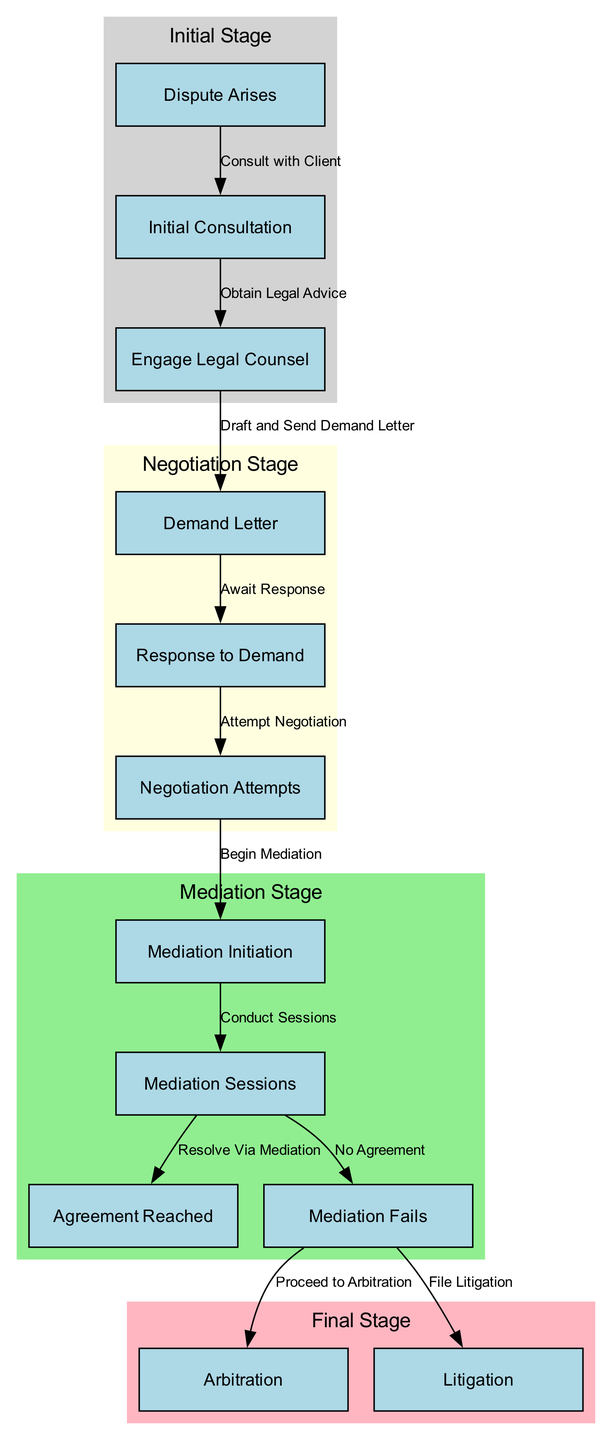What is the first step in the dispute resolution procedure? The first node in the diagram is labeled "Dispute Arises," indicating that it is the initial step in the timeline of the dispute resolution process.
Answer: Dispute Arises How many nodes are in the diagram? By counting the total number of unique nodes listed in the data, there are 12 nodes that represent various stages of the dispute resolution process.
Answer: 12 What stage follows "Response to Demand"? The edge connects "Response to Demand" to "Negotiation Attempts," which indicates that the next stage in the procedure involves attempts to negotiate following the receipt of a response to the demand letter.
Answer: Negotiation Attempts If mediation fails, what are the next two possible steps? From the "Mediation Fails" node, there are two outgoing edges leading to "Arbitration" and "Litigation," signifying that if mediation is unsuccessful, the parties can choose to either proceed to arbitration or file litigation.
Answer: Arbitration and Litigation What color represents the Mediation Stage in the diagram? The Mediation Stage is enclosed in a cluster with the label "Mediation Stage" and is described as having a light green color, which visually differentiates it from other stages in the timeline.
Answer: Light green What are the last two steps in the process? In reviewing the diagram, the two final steps indicated in the dispute resolution procedure are "Arbitration" and "Litigation," both of which are categorized under the Final Stage cluster.
Answer: Arbitration and Litigation What action is taken after the Demand Letter? After the issuance of the Demand Letter, the expected action is to "Await Response," which is represented as the node directly connected to the Demand Letter node in the flow of the diagram.
Answer: Await Response What is the relationship between "Mediation Sessions" and "Agreement Reached"? The edge connecting "Mediation Sessions" to "Agreement Reached" signifies that successful resolution of disputes may occur during the mediation sessions, indicating a direct outcome from these sessions.
Answer: Successful resolution How many stages are depicted in the diagram? The diagram is organized into four distinct stages: Initial Stage, Negotiation Stage, Mediation Stage, and Final Stage, which collectively illustrate the process of dispute resolution.
Answer: Four stages 